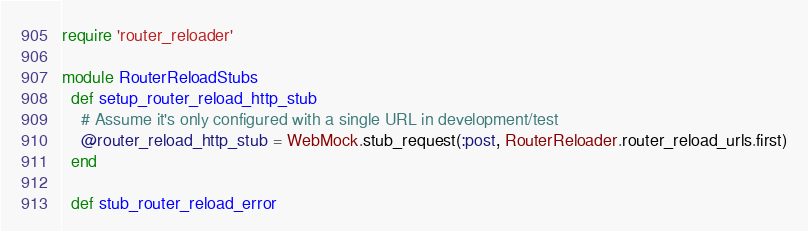<code> <loc_0><loc_0><loc_500><loc_500><_Ruby_>require 'router_reloader'

module RouterReloadStubs
  def setup_router_reload_http_stub
    # Assume it's only configured with a single URL in development/test
    @router_reload_http_stub = WebMock.stub_request(:post, RouterReloader.router_reload_urls.first)
  end

  def stub_router_reload_error</code> 